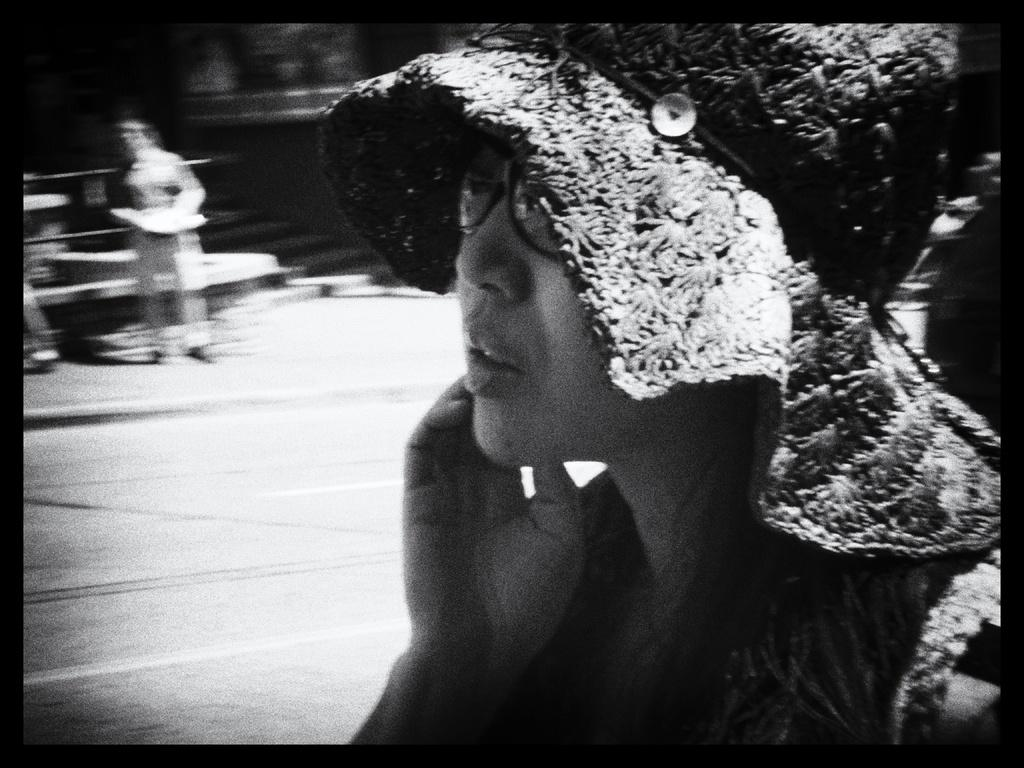What is the color scheme of the image? The image is black and white. What can be seen in the image besides the color scheme? There is a lady wearing a hat in the image. Are there any other people in the image? Yes, there are people standing behind the lady in the image. How many chairs are visible in the image? There are no chairs present in the image. What type of cave can be seen in the background of the image? There is no cave present in the image; it is a black and white photograph featuring a lady wearing a hat and people standing behind her. 